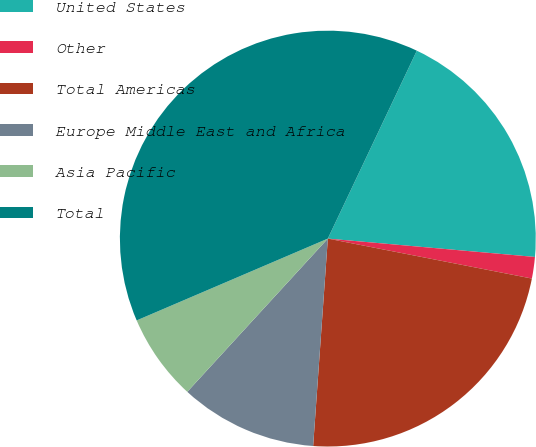Convert chart to OTSL. <chart><loc_0><loc_0><loc_500><loc_500><pie_chart><fcel>United States<fcel>Other<fcel>Total Americas<fcel>Europe Middle East and Africa<fcel>Asia Pacific<fcel>Total<nl><fcel>19.37%<fcel>1.67%<fcel>23.05%<fcel>10.69%<fcel>6.75%<fcel>38.48%<nl></chart> 